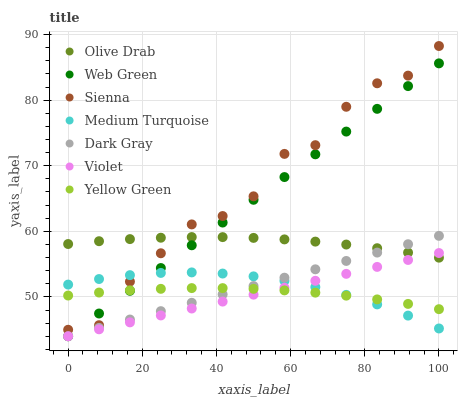Does Violet have the minimum area under the curve?
Answer yes or no. Yes. Does Sienna have the maximum area under the curve?
Answer yes or no. Yes. Does Yellow Green have the minimum area under the curve?
Answer yes or no. No. Does Yellow Green have the maximum area under the curve?
Answer yes or no. No. Is Violet the smoothest?
Answer yes or no. Yes. Is Sienna the roughest?
Answer yes or no. Yes. Is Yellow Green the smoothest?
Answer yes or no. No. Is Yellow Green the roughest?
Answer yes or no. No. Does Dark Gray have the lowest value?
Answer yes or no. Yes. Does Yellow Green have the lowest value?
Answer yes or no. No. Does Sienna have the highest value?
Answer yes or no. Yes. Does Web Green have the highest value?
Answer yes or no. No. Is Yellow Green less than Olive Drab?
Answer yes or no. Yes. Is Olive Drab greater than Yellow Green?
Answer yes or no. Yes. Does Web Green intersect Olive Drab?
Answer yes or no. Yes. Is Web Green less than Olive Drab?
Answer yes or no. No. Is Web Green greater than Olive Drab?
Answer yes or no. No. Does Yellow Green intersect Olive Drab?
Answer yes or no. No. 